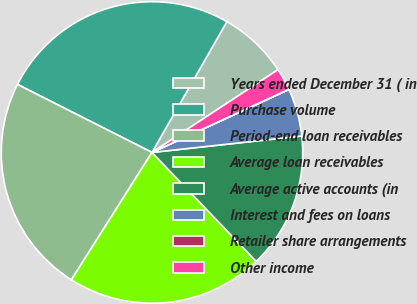<chart> <loc_0><loc_0><loc_500><loc_500><pie_chart><fcel>Years ended December 31 ( in<fcel>Purchase volume<fcel>Period-end loan receivables<fcel>Average loan receivables<fcel>Average active accounts (in<fcel>Interest and fees on loans<fcel>Retailer share arrangements<fcel>Other income<nl><fcel>7.47%<fcel>25.83%<fcel>23.48%<fcel>21.13%<fcel>14.59%<fcel>5.12%<fcel>0.02%<fcel>2.37%<nl></chart> 